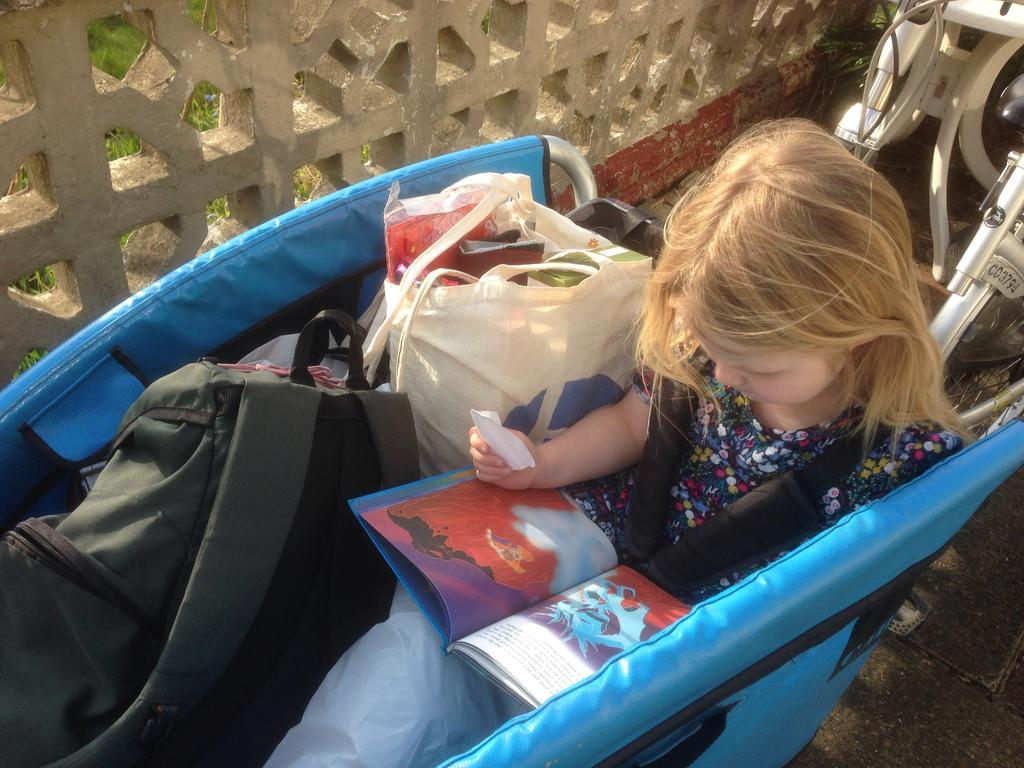Who is the main subject in the image? There is a girl in the image. What is the girl sitting on? The girl is sitting on a blue object. What is the girl holding or interacting with? There is a book on the girl's lap. What else can be seen near the girl? There are bags near the girl. What is visible in the background of the image? There is a wall in the image. What type of brass instrument is the girl playing in the image? There is no brass instrument present in the image; the girl is holding a book on her lap. Can you tell me how many eggnogs the girl is holding in the image? There is no eggnog present in the image; the girl is holding a book on her lap. 